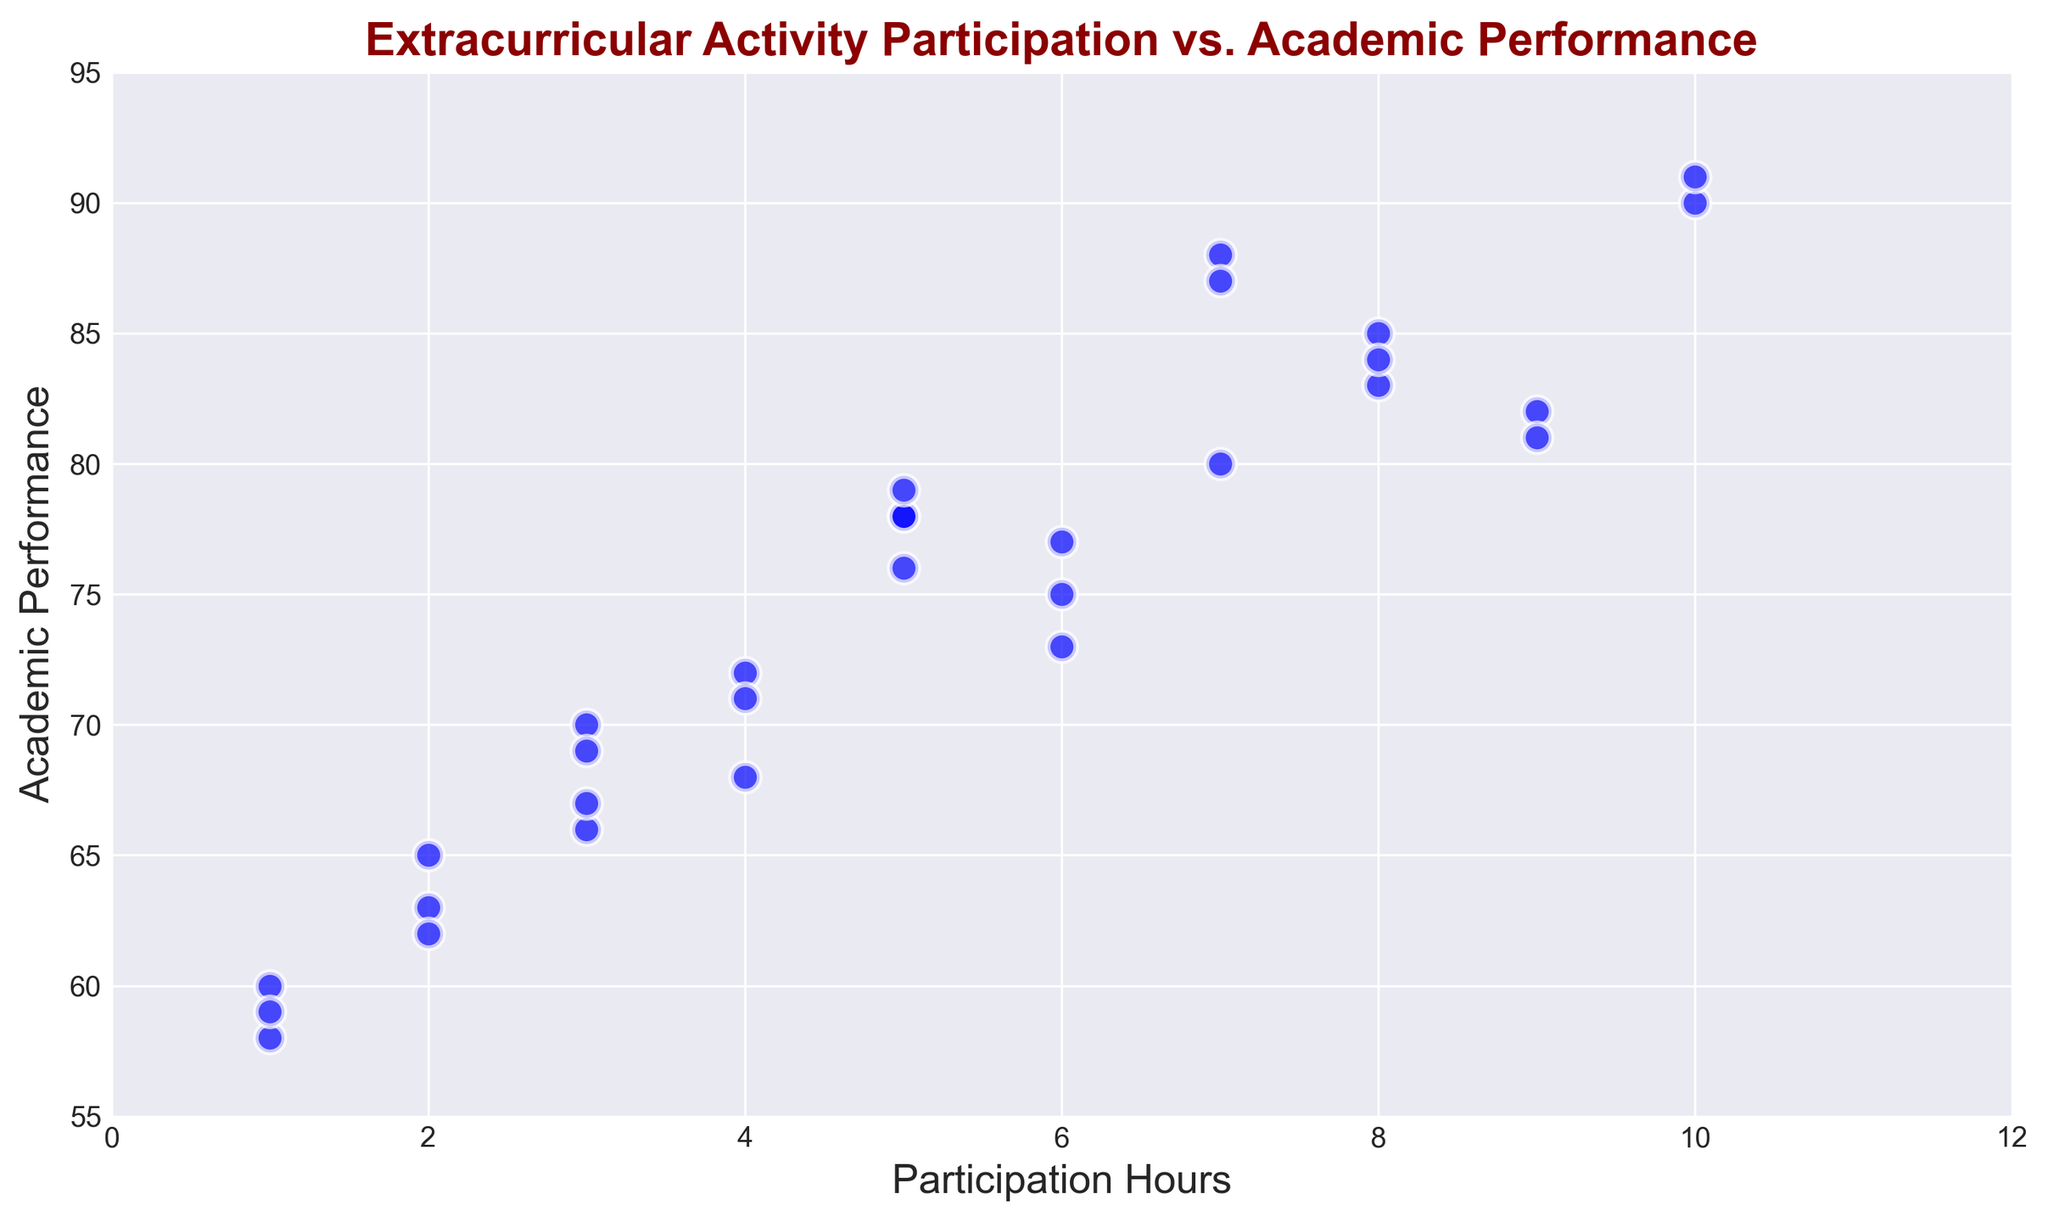What is the range of Academic Performance values shown in the plot? The Academic Performance values range from the lowest point visible on the plot (around 58) to the highest point (around 91).
Answer: 58 to 91 How does the academic performance vary with 5 hours of participation? There are several data points corresponding to 5 hours of participation. The academic performances seen at this participation level are around 76, 78, and 79.
Answer: Around 76, 78, 79 Which student has the highest Academic Performance, and how many participation hours do they have? The highest academic performance on the plot is around 91, corresponding to 10 participation hours.
Answer: 10 participation hours Is there a visible trend in how Academic Performance changes with increasing Participation Hours? The scatter plot shows a positive trend, where increased participation hours generally correspond to higher academic performance.
Answer: Positive trend Are there any outliers where students with low participation have high academic performance? Observing the plot, no significant outliers appear where students with very low participation (1 or 2 hours) have high academic performance.
Answer: No What are the participation hours for students scoring exactly 80 in Academic Performance? Students who have an academic performance of 80 have participation hours of around 7.
Answer: 7 hours Which Participation Hours range has the highest density of students? The highest density of students in the plot is around 4-6 participation hours.
Answer: 4-6 hours Compare the academic performance of students with 1 hour of participation to those with 10 hours. Observing the plot, students with 1 hour of participation have academic performances around 58-60, whereas those with 10 hours have performances around 90-91.
Answer: 1 hour: 58-60, 10 hours: 90-91 What is the average Academic Performance of students with 8 or more Participation Hours? Considering the provided data, students with 8, 9, and 10 hours have performances of 85, 83, 84, 81, 82, 87, 91, 90. The sum is 683; the count is 8. So, average = 683/8 = 85.375.
Answer: 85.375 